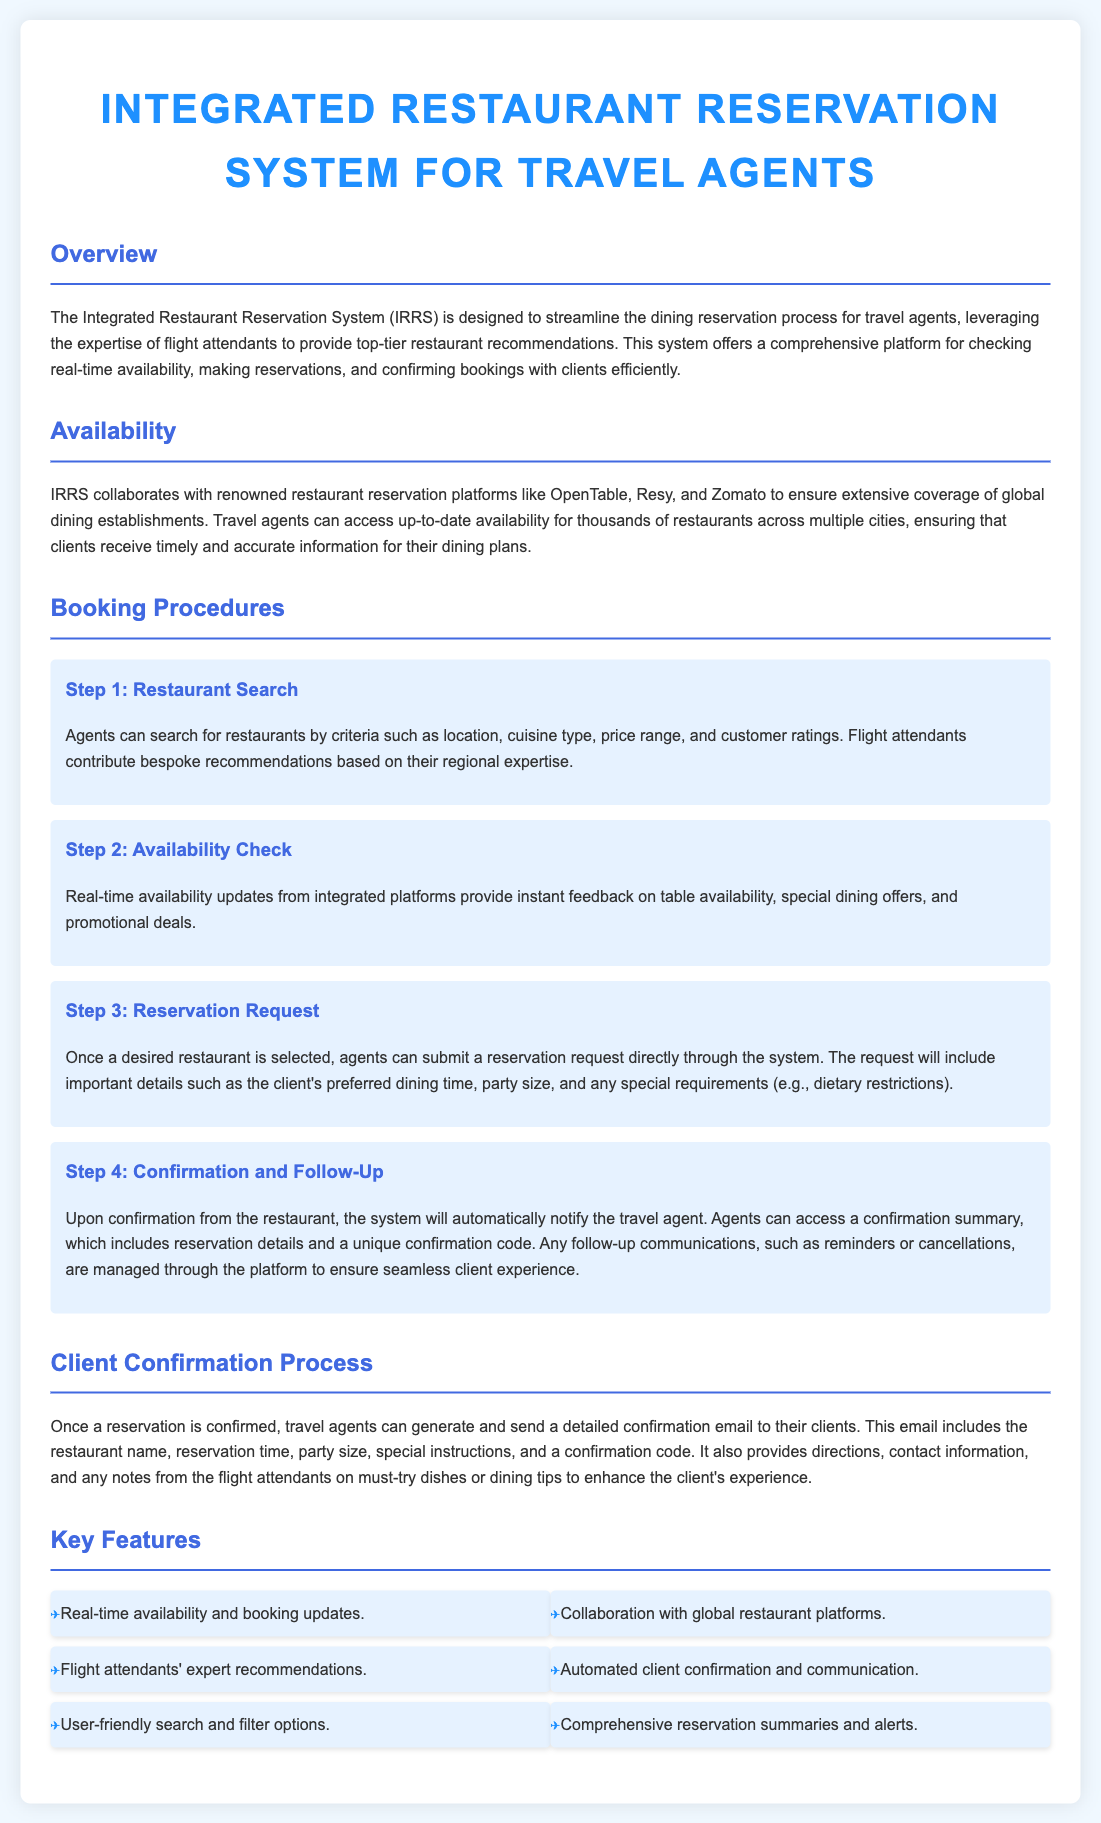What is the purpose of the Integrated Restaurant Reservation System? The system is designed to streamline the dining reservation process for travel agents by leveraging flight attendants' expertise for restaurant recommendations.
Answer: Streamline dining reservations Which platforms does IRRS collaborate with? The document states that IRRS collaborates with renowned restaurant reservation platforms like OpenTable, Resy, and Zomato.
Answer: OpenTable, Resy, Zomato What is the first step in the booking procedures? The first step in the booking procedures is searching for restaurants by various criteria such as location, cuisine type, price range, and customer ratings.
Answer: Restaurant Search How are clients notified of confirmation? Clients are notified through a detailed confirmation email generated and sent by travel agents once the reservation is confirmed.
Answer: Email What type of recommendations do flight attendants provide? Flight attendants provide bespoke recommendations based on their regional expertise.
Answer: Bespoke recommendations How many key features are listed in the document? The document lists six key features of the Integrated Restaurant Reservation System.
Answer: Six What is included in the confirmation email sent to clients? The confirmation email includes details like the restaurant name, reservation time, party size, special instructions, and a confirmation code.
Answer: Reservation details What type of updates does IRRS provide? IRRS provides real-time availability and booking updates.
Answer: Real-time updates 